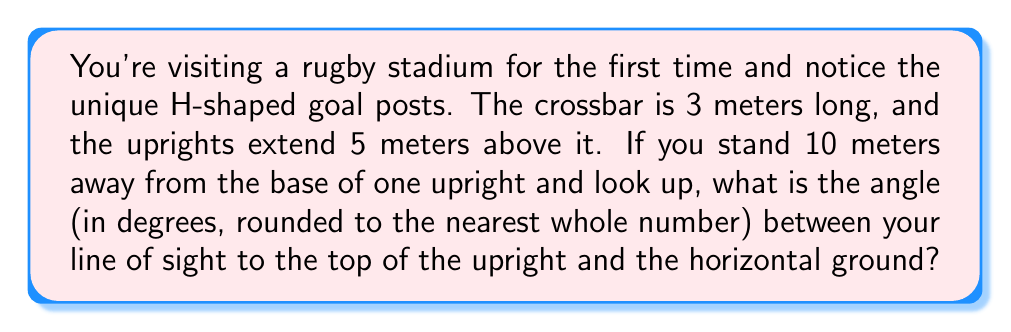Teach me how to tackle this problem. Let's approach this step-by-step:

1) First, we need to visualize the problem. We have a right triangle where:
   - The base is the distance from you to the goal post (10 meters)
   - The height is the total height of the goal post (3 + 5 = 8 meters)
   - The angle we're looking for is the one between the ground and your line of sight

2) We can represent this situation with the following diagram:

[asy]
import geometry;

size(200);

pair A = (0,0), B = (10,0), C = (10,8);
draw(A--B--C--A);

label("You", A, SW);
label("Goal post base", B, SE);
label("Top of upright", C, NE);
label("10 m", (A+B)/2, S);
label("8 m", (B+C)/2, E);
label("$\theta$", A, NE);

draw(A--(-1,0), arrow=Arrow());
draw((-1,0)--(-1,1), arrow=Arrow());
label("Ground", (-2,0.5), W);
label("Vertical", (-1.5,1), N);
[/asy]

3) This is a classic tangent ratio problem in trigonometry. The tangent of an angle in a right triangle is the ratio of the opposite side to the adjacent side.

4) In this case:
   $\tan \theta = \frac{\text{opposite}}{\text{adjacent}} = \frac{8}{10} = 0.8$

5) To find the angle, we need to use the inverse tangent (arctan or $\tan^{-1}$):

   $\theta = \tan^{-1}(0.8)$

6) Using a calculator or computer:

   $\theta \approx 38.66$ degrees

7) Rounding to the nearest whole number:

   $\theta \approx 39$ degrees
Answer: 39° 